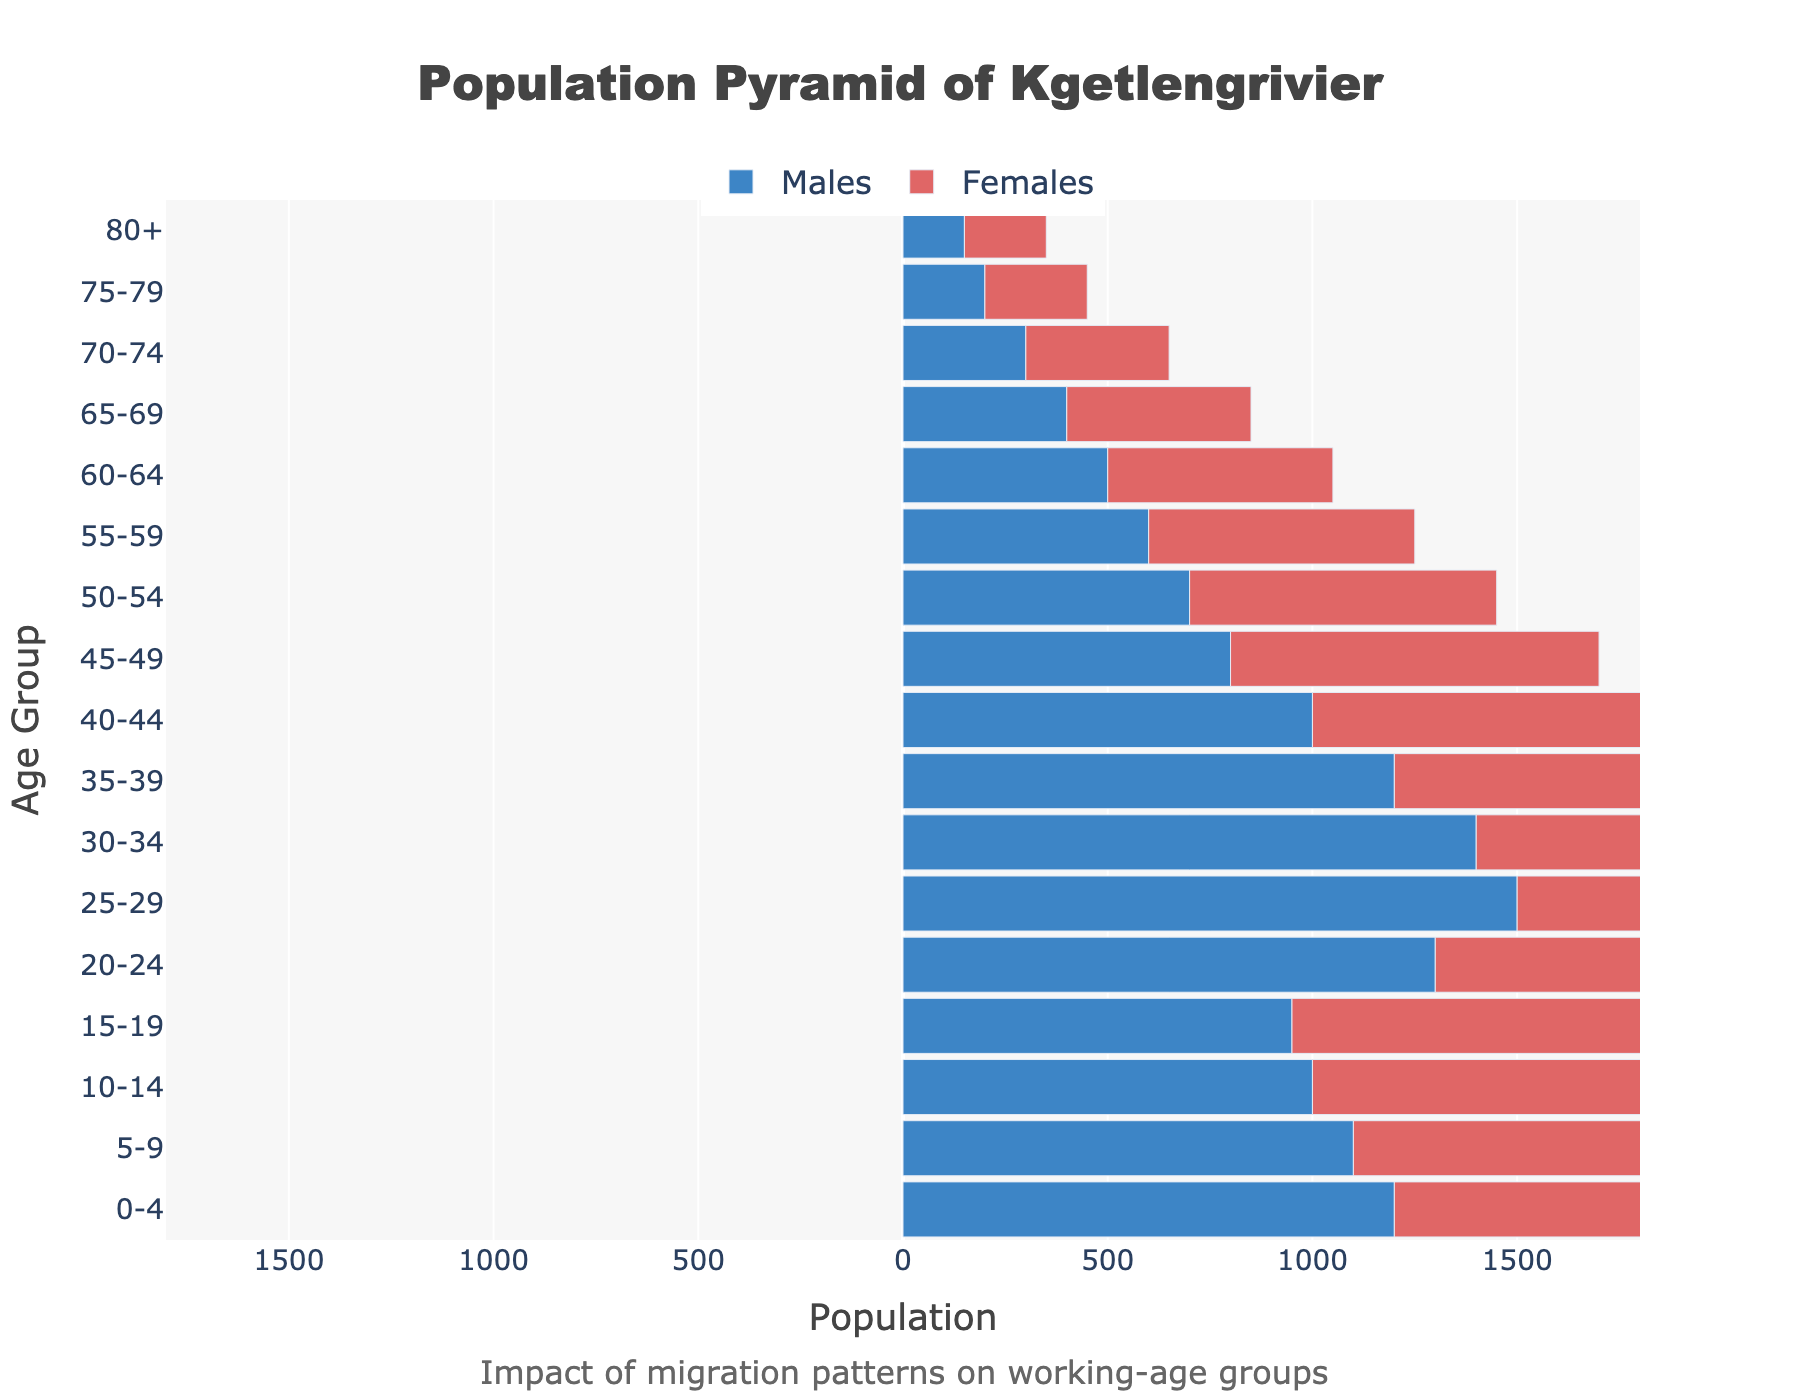How many age groups are represented in the population pyramid? The population pyramid lists age groups on the y-axis, from 0-4 to 80+. Counting these groups gives us the total number of age groups.
Answer: 17 What does the title of the figure indicate? The title is prominently displayed at the top of the figure, stating its main focus.
Answer: Population Pyramid of Kgetlengrivier Which age group has the largest male population? Check the length of the bars for males (negative values on the x-axis) to identify the longest one. The 25-29 age group has the longest bar for males at -1500.
Answer: 25-29 In which age group is the female population larger than the male population by the greatest margin? Calculate the difference between female and male populations for each age group. The 20-24 age group has the largest difference (1400 - 1300 = 100).
Answer: 20-24 How does the male population trend compared to the female population across age groups? Observe and interpret the overall shape of the bars for both males and females. The male population generally decreases more consistently across the age groups, whereas the female population sees a spike in the 20-24 and 25-29 age groups before declining.
Answer: Male population decreases consistently; female population has spikes Which age group shows a significant male outmigration potentially due to labor opportunities? Look for a significant drop in the male population in working-age groups. The 25-29 age group shows a marked reduction, suggesting potential outmigration (labor opportunities or other reasons).
Answer: 25-29 What does the annotation at the bottom of the figure suggest? Read the text at the bottom of the figure, which provides additional context for interpretation.
Answer: Impact of migration patterns on working-age groups 